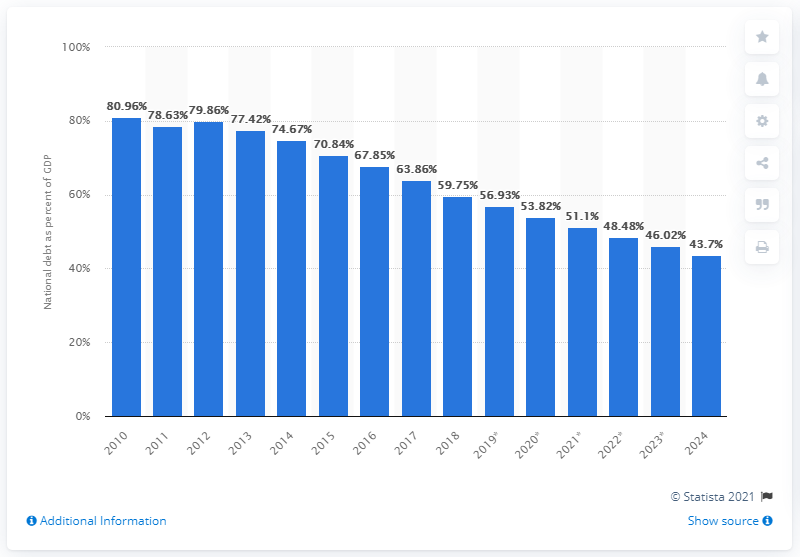Point out several critical features in this image. The national debt of Germany is projected to reach a projection for the year 2024. 